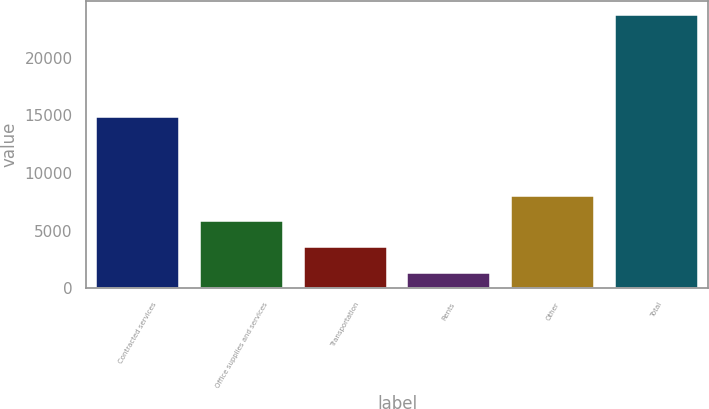Convert chart to OTSL. <chart><loc_0><loc_0><loc_500><loc_500><bar_chart><fcel>Contracted services<fcel>Office supplies and services<fcel>Transportation<fcel>Rents<fcel>Other<fcel>Total<nl><fcel>14824<fcel>5805.6<fcel>3564.8<fcel>1324<fcel>8046.4<fcel>23732<nl></chart> 